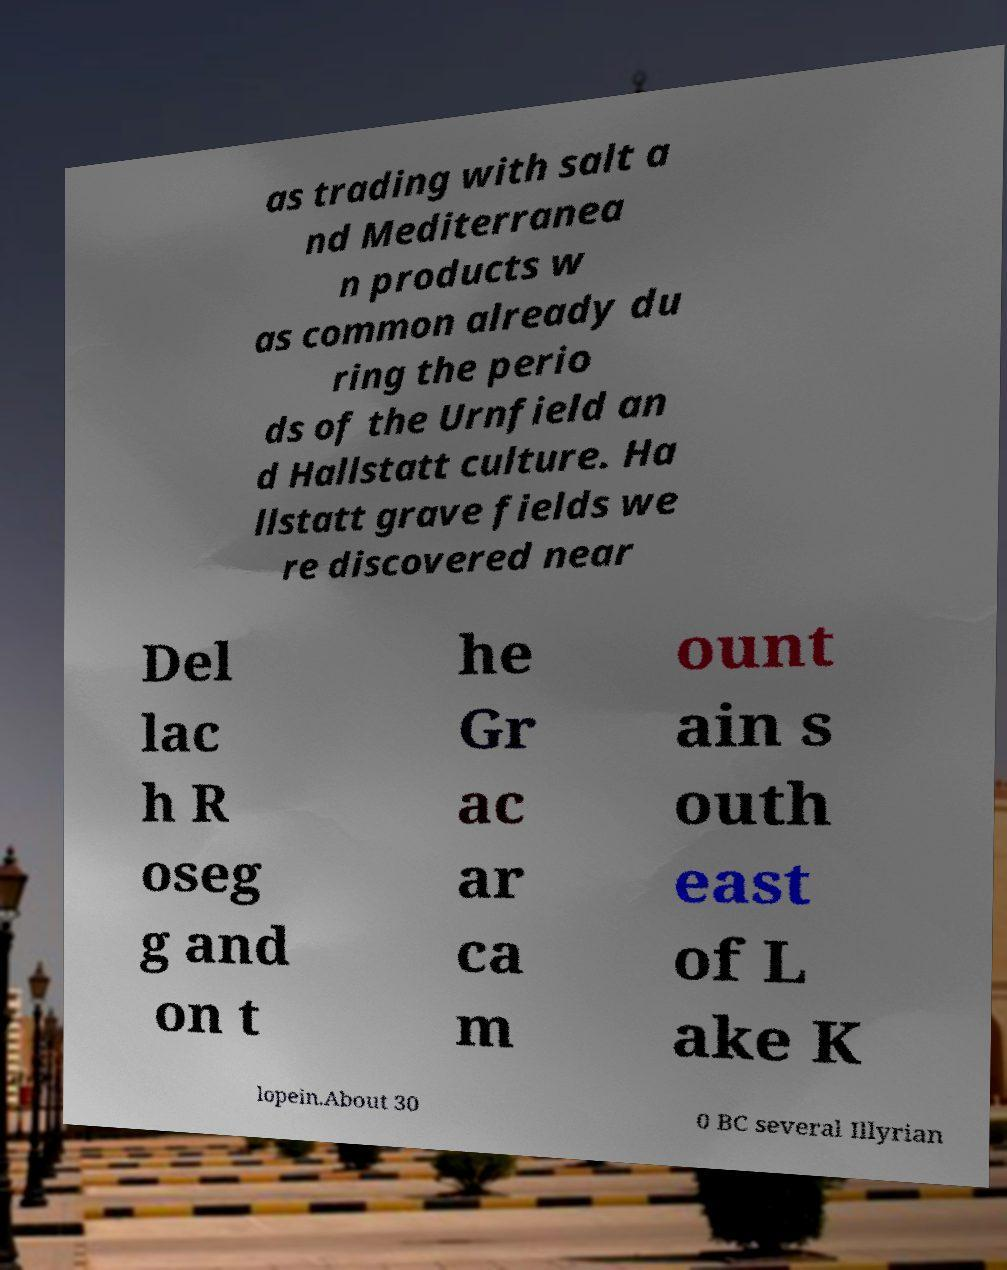Could you assist in decoding the text presented in this image and type it out clearly? as trading with salt a nd Mediterranea n products w as common already du ring the perio ds of the Urnfield an d Hallstatt culture. Ha llstatt grave fields we re discovered near Del lac h R oseg g and on t he Gr ac ar ca m ount ain s outh east of L ake K lopein.About 30 0 BC several Illyrian 